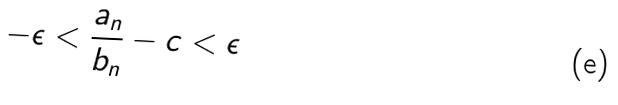<formula> <loc_0><loc_0><loc_500><loc_500>- \epsilon < \frac { a _ { n } } { b _ { n } } - c < \epsilon</formula> 